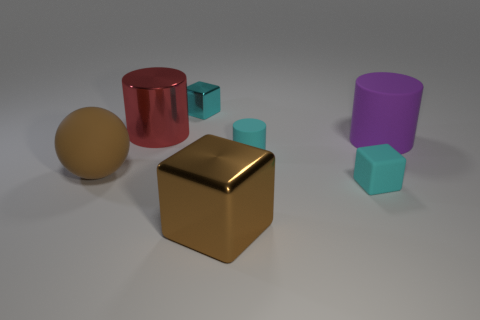Is there a large purple matte object of the same shape as the cyan metallic object?
Your answer should be very brief. No. What is the size of the thing on the left side of the cylinder on the left side of the small object left of the cyan cylinder?
Offer a very short reply. Large. Is the number of small things that are on the left side of the cyan metallic thing the same as the number of cyan metal cubes that are behind the big purple cylinder?
Your answer should be very brief. No. What size is the purple cylinder that is made of the same material as the big ball?
Provide a short and direct response. Large. What is the color of the rubber block?
Provide a short and direct response. Cyan. How many large cylinders are the same color as the small matte cylinder?
Provide a short and direct response. 0. There is another cyan block that is the same size as the cyan rubber cube; what is it made of?
Your answer should be very brief. Metal. Is there a purple rubber cylinder that is to the right of the object right of the tiny cyan matte cube?
Make the answer very short. No. How many other objects are there of the same color as the tiny rubber block?
Your answer should be very brief. 2. The brown rubber sphere is what size?
Offer a very short reply. Large. 